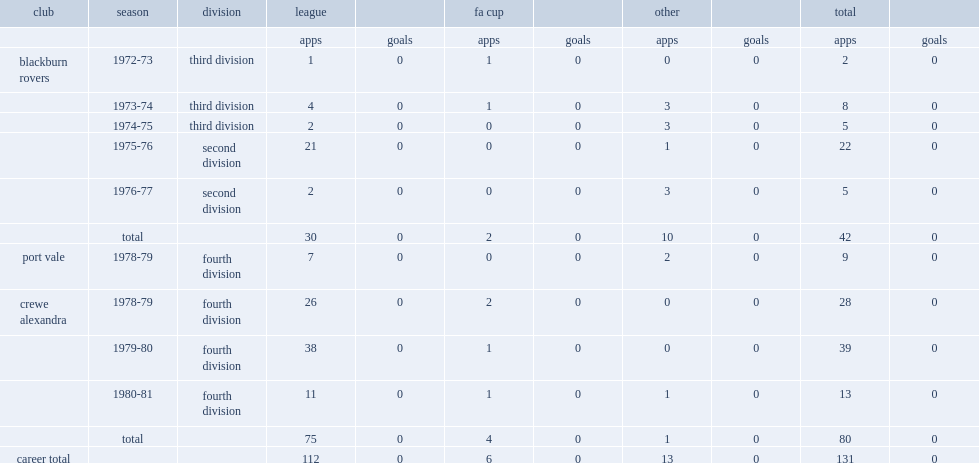How many appearances did neil wilkinson make in his career for blackburn rovers, port vale and crewe alexandra? 112.0. Could you help me parse every detail presented in this table? {'header': ['club', 'season', 'division', 'league', '', 'fa cup', '', 'other', '', 'total', ''], 'rows': [['', '', '', 'apps', 'goals', 'apps', 'goals', 'apps', 'goals', 'apps', 'goals'], ['blackburn rovers', '1972-73', 'third division', '1', '0', '1', '0', '0', '0', '2', '0'], ['', '1973-74', 'third division', '4', '0', '1', '0', '3', '0', '8', '0'], ['', '1974-75', 'third division', '2', '0', '0', '0', '3', '0', '5', '0'], ['', '1975-76', 'second division', '21', '0', '0', '0', '1', '0', '22', '0'], ['', '1976-77', 'second division', '2', '0', '0', '0', '3', '0', '5', '0'], ['', 'total', '', '30', '0', '2', '0', '10', '0', '42', '0'], ['port vale', '1978-79', 'fourth division', '7', '0', '0', '0', '2', '0', '9', '0'], ['crewe alexandra', '1978-79', 'fourth division', '26', '0', '2', '0', '0', '0', '28', '0'], ['', '1979-80', 'fourth division', '38', '0', '1', '0', '0', '0', '39', '0'], ['', '1980-81', 'fourth division', '11', '0', '1', '0', '1', '0', '13', '0'], ['', 'total', '', '75', '0', '4', '0', '1', '0', '80', '0'], ['career total', '', '', '112', '0', '6', '0', '13', '0', '131', '0']]} 